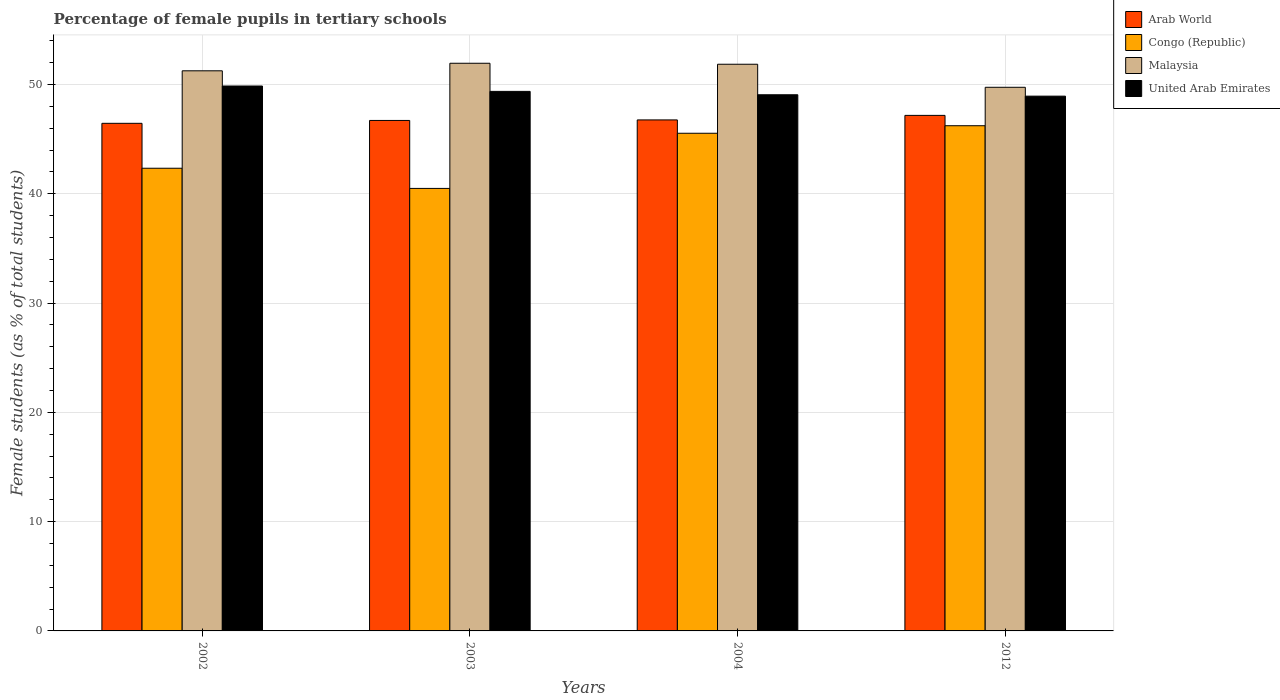Are the number of bars per tick equal to the number of legend labels?
Keep it short and to the point. Yes. In how many cases, is the number of bars for a given year not equal to the number of legend labels?
Provide a succinct answer. 0. What is the percentage of female pupils in tertiary schools in United Arab Emirates in 2002?
Ensure brevity in your answer.  49.86. Across all years, what is the maximum percentage of female pupils in tertiary schools in Arab World?
Offer a terse response. 47.17. Across all years, what is the minimum percentage of female pupils in tertiary schools in Arab World?
Your answer should be compact. 46.45. In which year was the percentage of female pupils in tertiary schools in Arab World maximum?
Ensure brevity in your answer.  2012. What is the total percentage of female pupils in tertiary schools in Arab World in the graph?
Ensure brevity in your answer.  187.09. What is the difference between the percentage of female pupils in tertiary schools in Arab World in 2003 and that in 2004?
Your answer should be very brief. -0.05. What is the difference between the percentage of female pupils in tertiary schools in United Arab Emirates in 2003 and the percentage of female pupils in tertiary schools in Arab World in 2004?
Provide a short and direct response. 2.61. What is the average percentage of female pupils in tertiary schools in Arab World per year?
Provide a succinct answer. 46.77. In the year 2002, what is the difference between the percentage of female pupils in tertiary schools in United Arab Emirates and percentage of female pupils in tertiary schools in Arab World?
Offer a very short reply. 3.41. In how many years, is the percentage of female pupils in tertiary schools in Arab World greater than 20 %?
Provide a succinct answer. 4. What is the ratio of the percentage of female pupils in tertiary schools in United Arab Emirates in 2002 to that in 2003?
Offer a very short reply. 1.01. Is the difference between the percentage of female pupils in tertiary schools in United Arab Emirates in 2002 and 2004 greater than the difference between the percentage of female pupils in tertiary schools in Arab World in 2002 and 2004?
Provide a succinct answer. Yes. What is the difference between the highest and the second highest percentage of female pupils in tertiary schools in Malaysia?
Your response must be concise. 0.09. What is the difference between the highest and the lowest percentage of female pupils in tertiary schools in Malaysia?
Offer a terse response. 2.2. Is it the case that in every year, the sum of the percentage of female pupils in tertiary schools in Malaysia and percentage of female pupils in tertiary schools in Congo (Republic) is greater than the sum of percentage of female pupils in tertiary schools in Arab World and percentage of female pupils in tertiary schools in United Arab Emirates?
Your answer should be very brief. No. What does the 4th bar from the left in 2004 represents?
Provide a short and direct response. United Arab Emirates. What does the 1st bar from the right in 2003 represents?
Your answer should be compact. United Arab Emirates. Is it the case that in every year, the sum of the percentage of female pupils in tertiary schools in Arab World and percentage of female pupils in tertiary schools in United Arab Emirates is greater than the percentage of female pupils in tertiary schools in Malaysia?
Keep it short and to the point. Yes. How many bars are there?
Offer a very short reply. 16. Are all the bars in the graph horizontal?
Your answer should be compact. No. How many years are there in the graph?
Provide a short and direct response. 4. What is the difference between two consecutive major ticks on the Y-axis?
Make the answer very short. 10. Does the graph contain grids?
Provide a succinct answer. Yes. Where does the legend appear in the graph?
Keep it short and to the point. Top right. How are the legend labels stacked?
Offer a very short reply. Vertical. What is the title of the graph?
Your answer should be very brief. Percentage of female pupils in tertiary schools. What is the label or title of the Y-axis?
Give a very brief answer. Female students (as % of total students). What is the Female students (as % of total students) in Arab World in 2002?
Ensure brevity in your answer.  46.45. What is the Female students (as % of total students) of Congo (Republic) in 2002?
Ensure brevity in your answer.  42.34. What is the Female students (as % of total students) of Malaysia in 2002?
Your answer should be very brief. 51.25. What is the Female students (as % of total students) of United Arab Emirates in 2002?
Make the answer very short. 49.86. What is the Female students (as % of total students) in Arab World in 2003?
Give a very brief answer. 46.71. What is the Female students (as % of total students) of Congo (Republic) in 2003?
Offer a very short reply. 40.49. What is the Female students (as % of total students) of Malaysia in 2003?
Give a very brief answer. 51.94. What is the Female students (as % of total students) in United Arab Emirates in 2003?
Your answer should be very brief. 49.37. What is the Female students (as % of total students) in Arab World in 2004?
Give a very brief answer. 46.76. What is the Female students (as % of total students) in Congo (Republic) in 2004?
Give a very brief answer. 45.54. What is the Female students (as % of total students) of Malaysia in 2004?
Provide a short and direct response. 51.85. What is the Female students (as % of total students) in United Arab Emirates in 2004?
Offer a very short reply. 49.06. What is the Female students (as % of total students) of Arab World in 2012?
Ensure brevity in your answer.  47.17. What is the Female students (as % of total students) of Congo (Republic) in 2012?
Keep it short and to the point. 46.23. What is the Female students (as % of total students) of Malaysia in 2012?
Offer a very short reply. 49.74. What is the Female students (as % of total students) in United Arab Emirates in 2012?
Offer a terse response. 48.93. Across all years, what is the maximum Female students (as % of total students) in Arab World?
Your answer should be compact. 47.17. Across all years, what is the maximum Female students (as % of total students) in Congo (Republic)?
Keep it short and to the point. 46.23. Across all years, what is the maximum Female students (as % of total students) of Malaysia?
Your answer should be very brief. 51.94. Across all years, what is the maximum Female students (as % of total students) in United Arab Emirates?
Your answer should be compact. 49.86. Across all years, what is the minimum Female students (as % of total students) of Arab World?
Your answer should be compact. 46.45. Across all years, what is the minimum Female students (as % of total students) of Congo (Republic)?
Ensure brevity in your answer.  40.49. Across all years, what is the minimum Female students (as % of total students) in Malaysia?
Make the answer very short. 49.74. Across all years, what is the minimum Female students (as % of total students) of United Arab Emirates?
Make the answer very short. 48.93. What is the total Female students (as % of total students) in Arab World in the graph?
Give a very brief answer. 187.09. What is the total Female students (as % of total students) of Congo (Republic) in the graph?
Your answer should be compact. 174.59. What is the total Female students (as % of total students) in Malaysia in the graph?
Your response must be concise. 204.79. What is the total Female students (as % of total students) of United Arab Emirates in the graph?
Make the answer very short. 197.22. What is the difference between the Female students (as % of total students) of Arab World in 2002 and that in 2003?
Ensure brevity in your answer.  -0.26. What is the difference between the Female students (as % of total students) in Congo (Republic) in 2002 and that in 2003?
Give a very brief answer. 1.85. What is the difference between the Female students (as % of total students) of Malaysia in 2002 and that in 2003?
Provide a short and direct response. -0.69. What is the difference between the Female students (as % of total students) in United Arab Emirates in 2002 and that in 2003?
Your response must be concise. 0.49. What is the difference between the Female students (as % of total students) of Arab World in 2002 and that in 2004?
Your answer should be very brief. -0.31. What is the difference between the Female students (as % of total students) in Congo (Republic) in 2002 and that in 2004?
Your answer should be compact. -3.2. What is the difference between the Female students (as % of total students) of Malaysia in 2002 and that in 2004?
Your answer should be compact. -0.6. What is the difference between the Female students (as % of total students) of United Arab Emirates in 2002 and that in 2004?
Your answer should be very brief. 0.8. What is the difference between the Female students (as % of total students) in Arab World in 2002 and that in 2012?
Keep it short and to the point. -0.73. What is the difference between the Female students (as % of total students) in Congo (Republic) in 2002 and that in 2012?
Provide a succinct answer. -3.89. What is the difference between the Female students (as % of total students) of Malaysia in 2002 and that in 2012?
Provide a short and direct response. 1.51. What is the difference between the Female students (as % of total students) of United Arab Emirates in 2002 and that in 2012?
Offer a very short reply. 0.93. What is the difference between the Female students (as % of total students) in Arab World in 2003 and that in 2004?
Your answer should be very brief. -0.05. What is the difference between the Female students (as % of total students) of Congo (Republic) in 2003 and that in 2004?
Your response must be concise. -5.05. What is the difference between the Female students (as % of total students) in Malaysia in 2003 and that in 2004?
Offer a terse response. 0.09. What is the difference between the Female students (as % of total students) in United Arab Emirates in 2003 and that in 2004?
Your answer should be compact. 0.31. What is the difference between the Female students (as % of total students) of Arab World in 2003 and that in 2012?
Your answer should be compact. -0.46. What is the difference between the Female students (as % of total students) in Congo (Republic) in 2003 and that in 2012?
Make the answer very short. -5.74. What is the difference between the Female students (as % of total students) of Malaysia in 2003 and that in 2012?
Your response must be concise. 2.2. What is the difference between the Female students (as % of total students) in United Arab Emirates in 2003 and that in 2012?
Ensure brevity in your answer.  0.44. What is the difference between the Female students (as % of total students) of Arab World in 2004 and that in 2012?
Your answer should be very brief. -0.41. What is the difference between the Female students (as % of total students) in Congo (Republic) in 2004 and that in 2012?
Offer a terse response. -0.69. What is the difference between the Female students (as % of total students) in Malaysia in 2004 and that in 2012?
Your response must be concise. 2.11. What is the difference between the Female students (as % of total students) of United Arab Emirates in 2004 and that in 2012?
Keep it short and to the point. 0.13. What is the difference between the Female students (as % of total students) in Arab World in 2002 and the Female students (as % of total students) in Congo (Republic) in 2003?
Provide a short and direct response. 5.96. What is the difference between the Female students (as % of total students) of Arab World in 2002 and the Female students (as % of total students) of Malaysia in 2003?
Provide a succinct answer. -5.5. What is the difference between the Female students (as % of total students) in Arab World in 2002 and the Female students (as % of total students) in United Arab Emirates in 2003?
Provide a succinct answer. -2.92. What is the difference between the Female students (as % of total students) of Congo (Republic) in 2002 and the Female students (as % of total students) of Malaysia in 2003?
Offer a very short reply. -9.61. What is the difference between the Female students (as % of total students) of Congo (Republic) in 2002 and the Female students (as % of total students) of United Arab Emirates in 2003?
Your answer should be very brief. -7.03. What is the difference between the Female students (as % of total students) in Malaysia in 2002 and the Female students (as % of total students) in United Arab Emirates in 2003?
Offer a terse response. 1.88. What is the difference between the Female students (as % of total students) in Arab World in 2002 and the Female students (as % of total students) in Congo (Republic) in 2004?
Ensure brevity in your answer.  0.91. What is the difference between the Female students (as % of total students) of Arab World in 2002 and the Female students (as % of total students) of Malaysia in 2004?
Offer a very short reply. -5.41. What is the difference between the Female students (as % of total students) of Arab World in 2002 and the Female students (as % of total students) of United Arab Emirates in 2004?
Make the answer very short. -2.61. What is the difference between the Female students (as % of total students) of Congo (Republic) in 2002 and the Female students (as % of total students) of Malaysia in 2004?
Give a very brief answer. -9.52. What is the difference between the Female students (as % of total students) of Congo (Republic) in 2002 and the Female students (as % of total students) of United Arab Emirates in 2004?
Your response must be concise. -6.72. What is the difference between the Female students (as % of total students) of Malaysia in 2002 and the Female students (as % of total students) of United Arab Emirates in 2004?
Give a very brief answer. 2.19. What is the difference between the Female students (as % of total students) of Arab World in 2002 and the Female students (as % of total students) of Congo (Republic) in 2012?
Give a very brief answer. 0.22. What is the difference between the Female students (as % of total students) in Arab World in 2002 and the Female students (as % of total students) in Malaysia in 2012?
Offer a very short reply. -3.3. What is the difference between the Female students (as % of total students) in Arab World in 2002 and the Female students (as % of total students) in United Arab Emirates in 2012?
Your answer should be compact. -2.49. What is the difference between the Female students (as % of total students) in Congo (Republic) in 2002 and the Female students (as % of total students) in Malaysia in 2012?
Your response must be concise. -7.41. What is the difference between the Female students (as % of total students) of Congo (Republic) in 2002 and the Female students (as % of total students) of United Arab Emirates in 2012?
Your answer should be compact. -6.6. What is the difference between the Female students (as % of total students) of Malaysia in 2002 and the Female students (as % of total students) of United Arab Emirates in 2012?
Offer a terse response. 2.32. What is the difference between the Female students (as % of total students) in Arab World in 2003 and the Female students (as % of total students) in Congo (Republic) in 2004?
Keep it short and to the point. 1.17. What is the difference between the Female students (as % of total students) in Arab World in 2003 and the Female students (as % of total students) in Malaysia in 2004?
Your answer should be compact. -5.14. What is the difference between the Female students (as % of total students) in Arab World in 2003 and the Female students (as % of total students) in United Arab Emirates in 2004?
Your answer should be compact. -2.35. What is the difference between the Female students (as % of total students) in Congo (Republic) in 2003 and the Female students (as % of total students) in Malaysia in 2004?
Make the answer very short. -11.36. What is the difference between the Female students (as % of total students) in Congo (Republic) in 2003 and the Female students (as % of total students) in United Arab Emirates in 2004?
Ensure brevity in your answer.  -8.57. What is the difference between the Female students (as % of total students) of Malaysia in 2003 and the Female students (as % of total students) of United Arab Emirates in 2004?
Ensure brevity in your answer.  2.88. What is the difference between the Female students (as % of total students) in Arab World in 2003 and the Female students (as % of total students) in Congo (Republic) in 2012?
Give a very brief answer. 0.48. What is the difference between the Female students (as % of total students) in Arab World in 2003 and the Female students (as % of total students) in Malaysia in 2012?
Provide a short and direct response. -3.03. What is the difference between the Female students (as % of total students) in Arab World in 2003 and the Female students (as % of total students) in United Arab Emirates in 2012?
Provide a short and direct response. -2.22. What is the difference between the Female students (as % of total students) of Congo (Republic) in 2003 and the Female students (as % of total students) of Malaysia in 2012?
Your answer should be very brief. -9.25. What is the difference between the Female students (as % of total students) of Congo (Republic) in 2003 and the Female students (as % of total students) of United Arab Emirates in 2012?
Keep it short and to the point. -8.44. What is the difference between the Female students (as % of total students) in Malaysia in 2003 and the Female students (as % of total students) in United Arab Emirates in 2012?
Ensure brevity in your answer.  3.01. What is the difference between the Female students (as % of total students) of Arab World in 2004 and the Female students (as % of total students) of Congo (Republic) in 2012?
Keep it short and to the point. 0.53. What is the difference between the Female students (as % of total students) in Arab World in 2004 and the Female students (as % of total students) in Malaysia in 2012?
Give a very brief answer. -2.99. What is the difference between the Female students (as % of total students) in Arab World in 2004 and the Female students (as % of total students) in United Arab Emirates in 2012?
Your response must be concise. -2.18. What is the difference between the Female students (as % of total students) of Congo (Republic) in 2004 and the Female students (as % of total students) of Malaysia in 2012?
Your answer should be very brief. -4.21. What is the difference between the Female students (as % of total students) in Congo (Republic) in 2004 and the Female students (as % of total students) in United Arab Emirates in 2012?
Ensure brevity in your answer.  -3.4. What is the difference between the Female students (as % of total students) of Malaysia in 2004 and the Female students (as % of total students) of United Arab Emirates in 2012?
Give a very brief answer. 2.92. What is the average Female students (as % of total students) of Arab World per year?
Provide a succinct answer. 46.77. What is the average Female students (as % of total students) of Congo (Republic) per year?
Ensure brevity in your answer.  43.65. What is the average Female students (as % of total students) of Malaysia per year?
Your answer should be very brief. 51.2. What is the average Female students (as % of total students) in United Arab Emirates per year?
Offer a very short reply. 49.31. In the year 2002, what is the difference between the Female students (as % of total students) in Arab World and Female students (as % of total students) in Congo (Republic)?
Give a very brief answer. 4.11. In the year 2002, what is the difference between the Female students (as % of total students) of Arab World and Female students (as % of total students) of Malaysia?
Give a very brief answer. -4.8. In the year 2002, what is the difference between the Female students (as % of total students) of Arab World and Female students (as % of total students) of United Arab Emirates?
Your answer should be very brief. -3.41. In the year 2002, what is the difference between the Female students (as % of total students) in Congo (Republic) and Female students (as % of total students) in Malaysia?
Provide a succinct answer. -8.92. In the year 2002, what is the difference between the Female students (as % of total students) in Congo (Republic) and Female students (as % of total students) in United Arab Emirates?
Your response must be concise. -7.52. In the year 2002, what is the difference between the Female students (as % of total students) of Malaysia and Female students (as % of total students) of United Arab Emirates?
Your answer should be very brief. 1.39. In the year 2003, what is the difference between the Female students (as % of total students) of Arab World and Female students (as % of total students) of Congo (Republic)?
Make the answer very short. 6.22. In the year 2003, what is the difference between the Female students (as % of total students) in Arab World and Female students (as % of total students) in Malaysia?
Your response must be concise. -5.23. In the year 2003, what is the difference between the Female students (as % of total students) in Arab World and Female students (as % of total students) in United Arab Emirates?
Make the answer very short. -2.66. In the year 2003, what is the difference between the Female students (as % of total students) in Congo (Republic) and Female students (as % of total students) in Malaysia?
Offer a very short reply. -11.45. In the year 2003, what is the difference between the Female students (as % of total students) of Congo (Republic) and Female students (as % of total students) of United Arab Emirates?
Your answer should be compact. -8.88. In the year 2003, what is the difference between the Female students (as % of total students) of Malaysia and Female students (as % of total students) of United Arab Emirates?
Give a very brief answer. 2.57. In the year 2004, what is the difference between the Female students (as % of total students) in Arab World and Female students (as % of total students) in Congo (Republic)?
Offer a very short reply. 1.22. In the year 2004, what is the difference between the Female students (as % of total students) in Arab World and Female students (as % of total students) in Malaysia?
Provide a succinct answer. -5.09. In the year 2004, what is the difference between the Female students (as % of total students) in Arab World and Female students (as % of total students) in United Arab Emirates?
Ensure brevity in your answer.  -2.3. In the year 2004, what is the difference between the Female students (as % of total students) in Congo (Republic) and Female students (as % of total students) in Malaysia?
Your response must be concise. -6.32. In the year 2004, what is the difference between the Female students (as % of total students) of Congo (Republic) and Female students (as % of total students) of United Arab Emirates?
Make the answer very short. -3.52. In the year 2004, what is the difference between the Female students (as % of total students) of Malaysia and Female students (as % of total students) of United Arab Emirates?
Give a very brief answer. 2.79. In the year 2012, what is the difference between the Female students (as % of total students) in Arab World and Female students (as % of total students) in Congo (Republic)?
Your answer should be compact. 0.95. In the year 2012, what is the difference between the Female students (as % of total students) of Arab World and Female students (as % of total students) of Malaysia?
Give a very brief answer. -2.57. In the year 2012, what is the difference between the Female students (as % of total students) of Arab World and Female students (as % of total students) of United Arab Emirates?
Keep it short and to the point. -1.76. In the year 2012, what is the difference between the Female students (as % of total students) of Congo (Republic) and Female students (as % of total students) of Malaysia?
Keep it short and to the point. -3.52. In the year 2012, what is the difference between the Female students (as % of total students) in Congo (Republic) and Female students (as % of total students) in United Arab Emirates?
Your response must be concise. -2.71. In the year 2012, what is the difference between the Female students (as % of total students) in Malaysia and Female students (as % of total students) in United Arab Emirates?
Make the answer very short. 0.81. What is the ratio of the Female students (as % of total students) of Congo (Republic) in 2002 to that in 2003?
Your answer should be compact. 1.05. What is the ratio of the Female students (as % of total students) in Malaysia in 2002 to that in 2003?
Provide a short and direct response. 0.99. What is the ratio of the Female students (as % of total students) in Congo (Republic) in 2002 to that in 2004?
Offer a terse response. 0.93. What is the ratio of the Female students (as % of total students) in Malaysia in 2002 to that in 2004?
Ensure brevity in your answer.  0.99. What is the ratio of the Female students (as % of total students) in United Arab Emirates in 2002 to that in 2004?
Ensure brevity in your answer.  1.02. What is the ratio of the Female students (as % of total students) of Arab World in 2002 to that in 2012?
Provide a short and direct response. 0.98. What is the ratio of the Female students (as % of total students) in Congo (Republic) in 2002 to that in 2012?
Ensure brevity in your answer.  0.92. What is the ratio of the Female students (as % of total students) of Malaysia in 2002 to that in 2012?
Your answer should be very brief. 1.03. What is the ratio of the Female students (as % of total students) of United Arab Emirates in 2002 to that in 2012?
Your answer should be compact. 1.02. What is the ratio of the Female students (as % of total students) of Congo (Republic) in 2003 to that in 2004?
Make the answer very short. 0.89. What is the ratio of the Female students (as % of total students) of United Arab Emirates in 2003 to that in 2004?
Your response must be concise. 1.01. What is the ratio of the Female students (as % of total students) in Arab World in 2003 to that in 2012?
Keep it short and to the point. 0.99. What is the ratio of the Female students (as % of total students) in Congo (Republic) in 2003 to that in 2012?
Provide a succinct answer. 0.88. What is the ratio of the Female students (as % of total students) in Malaysia in 2003 to that in 2012?
Offer a very short reply. 1.04. What is the ratio of the Female students (as % of total students) in United Arab Emirates in 2003 to that in 2012?
Your response must be concise. 1.01. What is the ratio of the Female students (as % of total students) in Congo (Republic) in 2004 to that in 2012?
Provide a short and direct response. 0.99. What is the ratio of the Female students (as % of total students) of Malaysia in 2004 to that in 2012?
Provide a short and direct response. 1.04. What is the difference between the highest and the second highest Female students (as % of total students) of Arab World?
Ensure brevity in your answer.  0.41. What is the difference between the highest and the second highest Female students (as % of total students) of Congo (Republic)?
Make the answer very short. 0.69. What is the difference between the highest and the second highest Female students (as % of total students) of Malaysia?
Make the answer very short. 0.09. What is the difference between the highest and the second highest Female students (as % of total students) of United Arab Emirates?
Give a very brief answer. 0.49. What is the difference between the highest and the lowest Female students (as % of total students) of Arab World?
Make the answer very short. 0.73. What is the difference between the highest and the lowest Female students (as % of total students) in Congo (Republic)?
Give a very brief answer. 5.74. What is the difference between the highest and the lowest Female students (as % of total students) of Malaysia?
Ensure brevity in your answer.  2.2. What is the difference between the highest and the lowest Female students (as % of total students) in United Arab Emirates?
Ensure brevity in your answer.  0.93. 